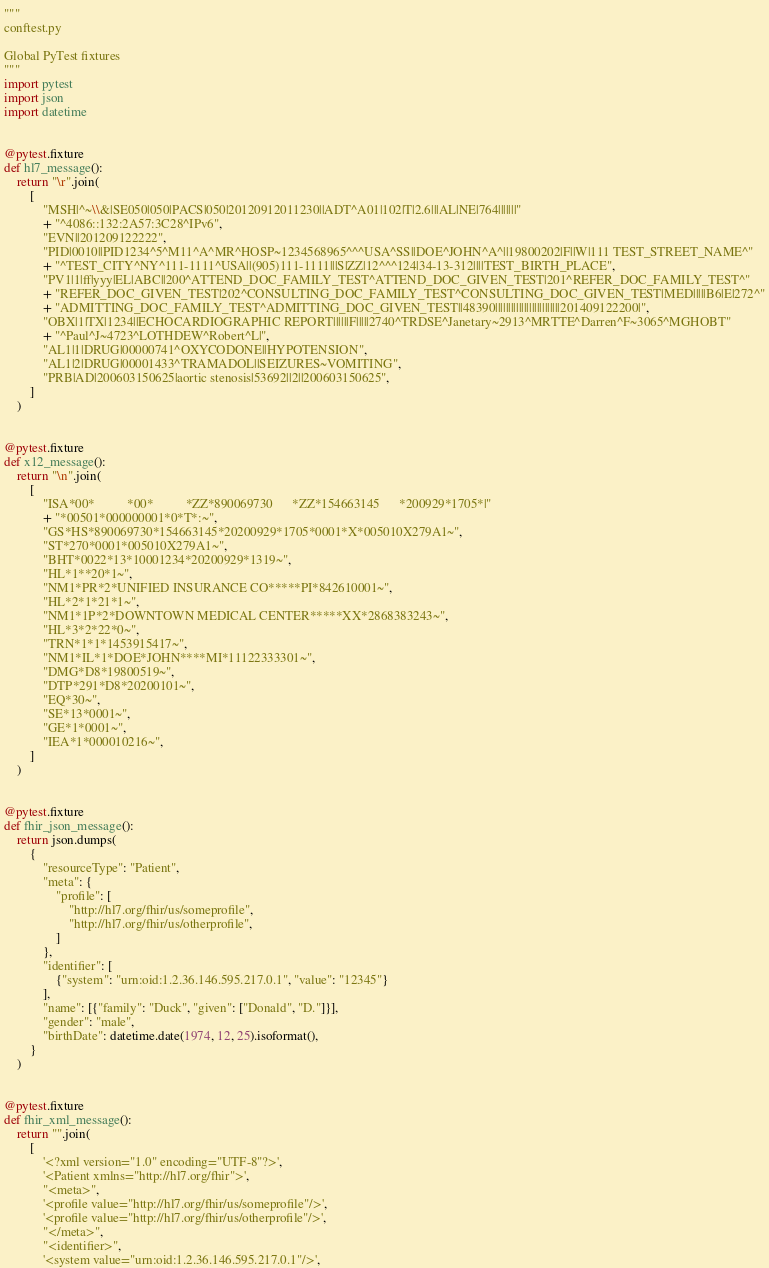<code> <loc_0><loc_0><loc_500><loc_500><_Python_>"""
conftest.py

Global PyTest fixtures
"""
import pytest
import json
import datetime


@pytest.fixture
def hl7_message():
    return "\r".join(
        [
            "MSH|^~\\&|SE050|050|PACS|050|20120912011230||ADT^A01|102|T|2.6|||AL|NE|764|||||||"
            + "^4086::132:2A57:3C28^IPv6",
            "EVN||201209122222",
            "PID|0010||PID1234^5^M11^A^MR^HOSP~1234568965^^^USA^SS||DOE^JOHN^A^||19800202|F||W|111 TEST_STREET_NAME^"
            + "^TEST_CITY^NY^111-1111^USA||(905)111-1111|||S|ZZ|12^^^124|34-13-312||||TEST_BIRTH_PLACE",
            "PV1|1|ff|yyy|EL|ABC||200^ATTEND_DOC_FAMILY_TEST^ATTEND_DOC_GIVEN_TEST|201^REFER_DOC_FAMILY_TEST^"
            + "REFER_DOC_GIVEN_TEST|202^CONSULTING_DOC_FAMILY_TEST^CONSULTING_DOC_GIVEN_TEST|MED|||||B6|E|272^"
            + "ADMITTING_DOC_FAMILY_TEST^ADMITTING_DOC_GIVEN_TEST||48390|||||||||||||||||||||||||201409122200|",
            "OBX|1|TX|1234||ECHOCARDIOGRAPHIC REPORT||||||F|||||2740^TRDSE^Janetary~2913^MRTTE^Darren^F~3065^MGHOBT"
            + "^Paul^J~4723^LOTHDEW^Robert^L|",
            "AL1|1|DRUG|00000741^OXYCODONE||HYPOTENSION",
            "AL1|2|DRUG|00001433^TRAMADOL||SEIZURES~VOMITING",
            "PRB|AD|200603150625|aortic stenosis|53692||2||200603150625",
        ]
    )


@pytest.fixture
def x12_message():
    return "\n".join(
        [
            "ISA*00*          *00*          *ZZ*890069730      *ZZ*154663145      *200929*1705*|"
            + "*00501*000000001*0*T*:~",
            "GS*HS*890069730*154663145*20200929*1705*0001*X*005010X279A1~",
            "ST*270*0001*005010X279A1~",
            "BHT*0022*13*10001234*20200929*1319~",
            "HL*1**20*1~",
            "NM1*PR*2*UNIFIED INSURANCE CO*****PI*842610001~",
            "HL*2*1*21*1~",
            "NM1*1P*2*DOWNTOWN MEDICAL CENTER*****XX*2868383243~",
            "HL*3*2*22*0~",
            "TRN*1*1*1453915417~",
            "NM1*IL*1*DOE*JOHN****MI*11122333301~",
            "DMG*D8*19800519~",
            "DTP*291*D8*20200101~",
            "EQ*30~",
            "SE*13*0001~",
            "GE*1*0001~",
            "IEA*1*000010216~",
        ]
    )


@pytest.fixture
def fhir_json_message():
    return json.dumps(
        {
            "resourceType": "Patient",
            "meta": {
                "profile": [
                    "http://hl7.org/fhir/us/someprofile",
                    "http://hl7.org/fhir/us/otherprofile",
                ]
            },
            "identifier": [
                {"system": "urn:oid:1.2.36.146.595.217.0.1", "value": "12345"}
            ],
            "name": [{"family": "Duck", "given": ["Donald", "D."]}],
            "gender": "male",
            "birthDate": datetime.date(1974, 12, 25).isoformat(),
        }
    )


@pytest.fixture
def fhir_xml_message():
    return "".join(
        [
            '<?xml version="1.0" encoding="UTF-8"?>',
            '<Patient xmlns="http://hl7.org/fhir">',
            "<meta>",
            '<profile value="http://hl7.org/fhir/us/someprofile"/>',
            '<profile value="http://hl7.org/fhir/us/otherprofile"/>',
            "</meta>",
            "<identifier>",
            '<system value="urn:oid:1.2.36.146.595.217.0.1"/>',</code> 